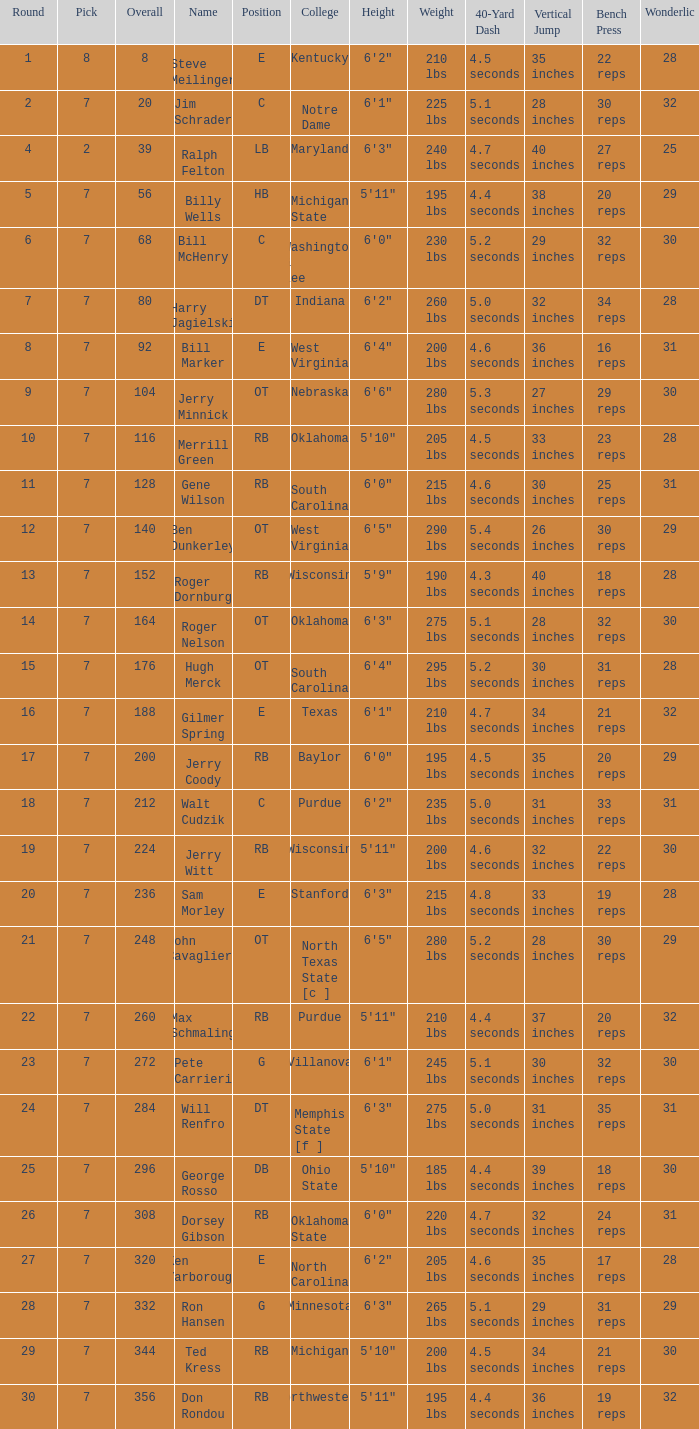What is the number of the round in which Ron Hansen was drafted and the overall is greater than 332? 0.0. 